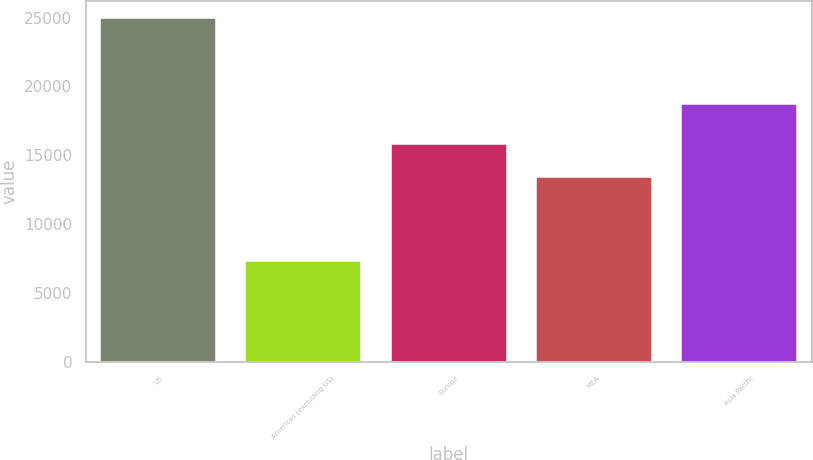Convert chart. <chart><loc_0><loc_0><loc_500><loc_500><bar_chart><fcel>US<fcel>Americas (excluding US)<fcel>Europe<fcel>MEA<fcel>Asia Pacific<nl><fcel>24939<fcel>7339<fcel>15798<fcel>13411<fcel>18738<nl></chart> 